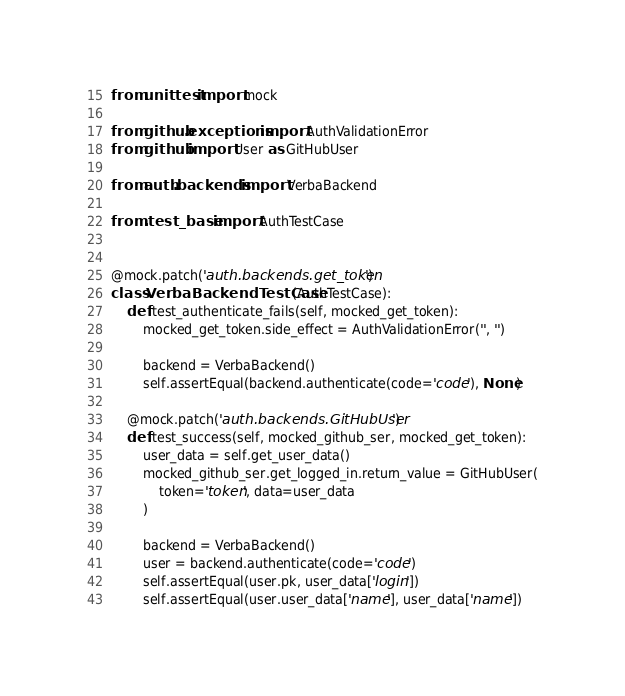Convert code to text. <code><loc_0><loc_0><loc_500><loc_500><_Python_>from unittest import mock

from github.exceptions import AuthValidationError
from github import User as GitHubUser

from auth.backends import VerbaBackend

from .test_base import AuthTestCase


@mock.patch('auth.backends.get_token')
class VerbaBackendTestCase(AuthTestCase):
    def test_authenticate_fails(self, mocked_get_token):
        mocked_get_token.side_effect = AuthValidationError('', '')

        backend = VerbaBackend()
        self.assertEqual(backend.authenticate(code='code'), None)

    @mock.patch('auth.backends.GitHubUser')
    def test_success(self, mocked_github_ser, mocked_get_token):
        user_data = self.get_user_data()
        mocked_github_ser.get_logged_in.return_value = GitHubUser(
            token='token', data=user_data
        )

        backend = VerbaBackend()
        user = backend.authenticate(code='code')
        self.assertEqual(user.pk, user_data['login'])
        self.assertEqual(user.user_data['name'], user_data['name'])
</code> 